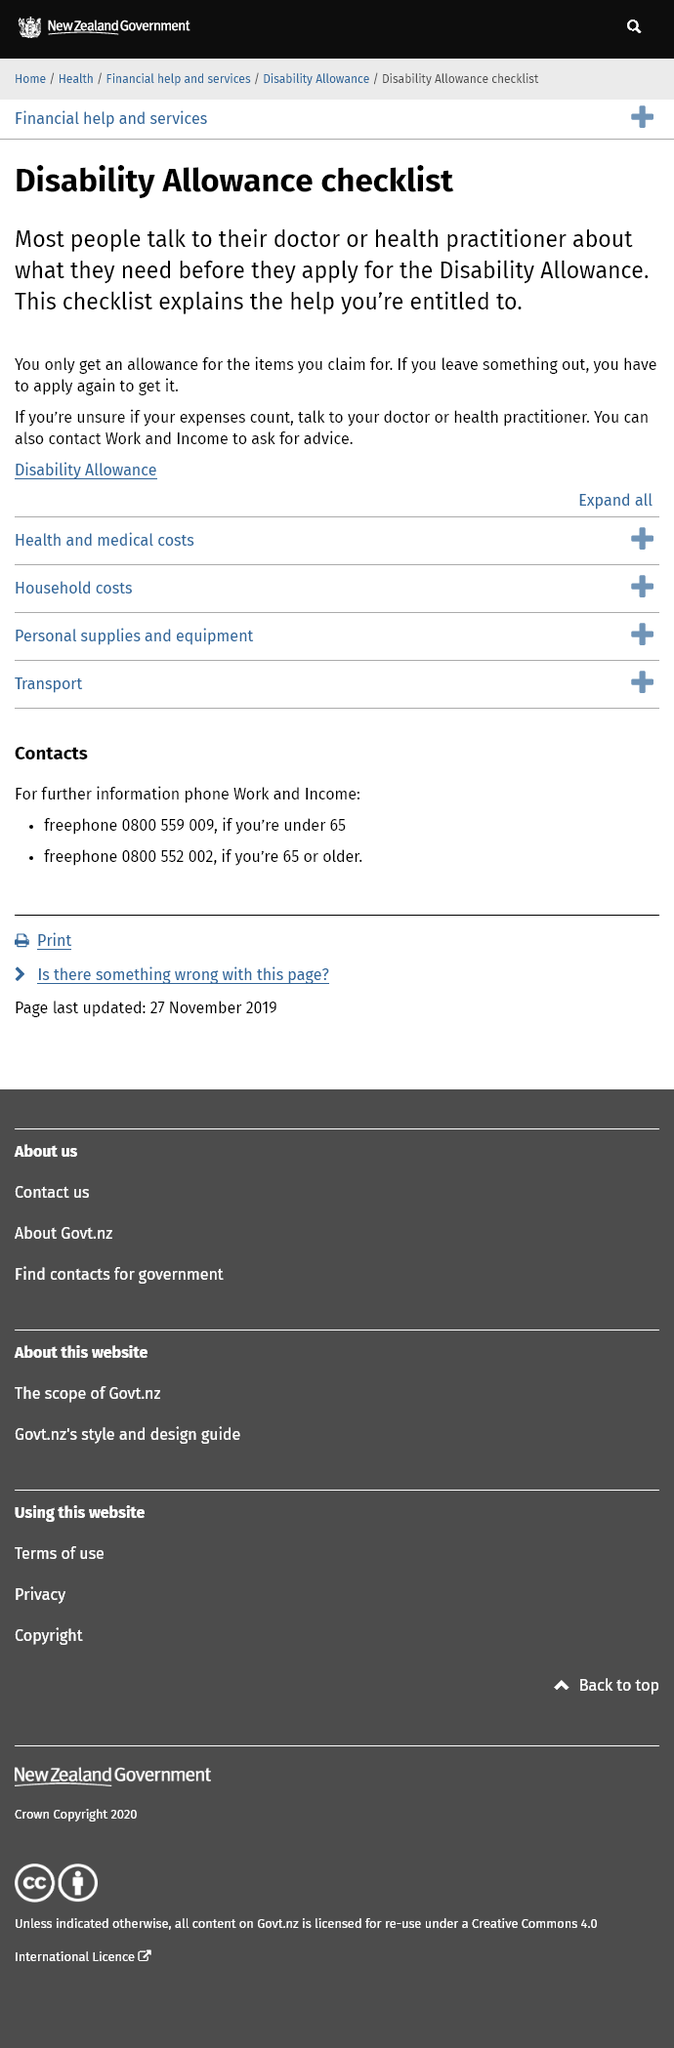Point out several critical features in this image. If something is left out, you will have to reapply. If you are under the age of 65 and require additional information, you should contact Work and Income by calling 0800 559 009. You can only receive allowance for items that you claim for. 